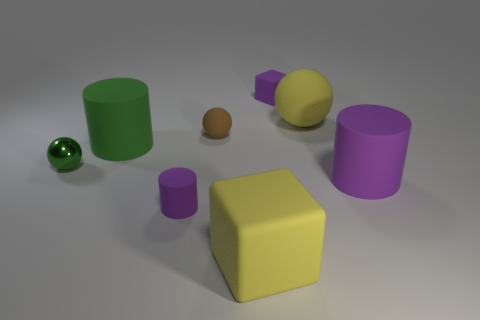There is a large cylinder that is to the right of the small purple matte block; how many large yellow objects are in front of it?
Your response must be concise. 1. Do the small shiny ball and the small matte ball have the same color?
Your response must be concise. No. How many other objects are the same material as the tiny purple cylinder?
Your response must be concise. 6. There is a large yellow matte thing that is to the left of the big yellow thing on the right side of the large matte block; what is its shape?
Provide a succinct answer. Cube. How big is the matte block that is behind the green shiny sphere?
Make the answer very short. Small. Is the material of the big purple thing the same as the small block?
Your response must be concise. Yes. The big purple thing that is the same material as the large yellow ball is what shape?
Keep it short and to the point. Cylinder. Is there any other thing of the same color as the small rubber sphere?
Ensure brevity in your answer.  No. There is a matte cube in front of the large green thing; what color is it?
Your answer should be very brief. Yellow. Is the color of the large cylinder on the right side of the purple matte block the same as the small metal sphere?
Your answer should be compact. No. 